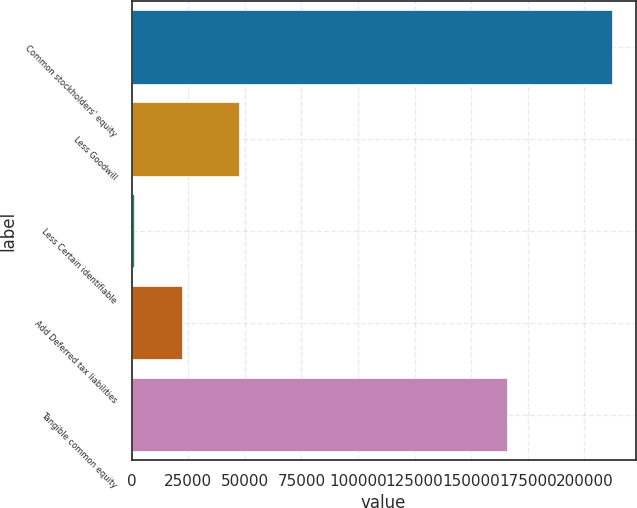Convert chart to OTSL. <chart><loc_0><loc_0><loc_500><loc_500><bar_chart><fcel>Common stockholders' equity<fcel>Less Goodwill<fcel>Less Certain identifiable<fcel>Add Deferred tax liabilities<fcel>Tangible common equity<nl><fcel>212002<fcel>47647<fcel>1192<fcel>22273<fcel>166016<nl></chart> 